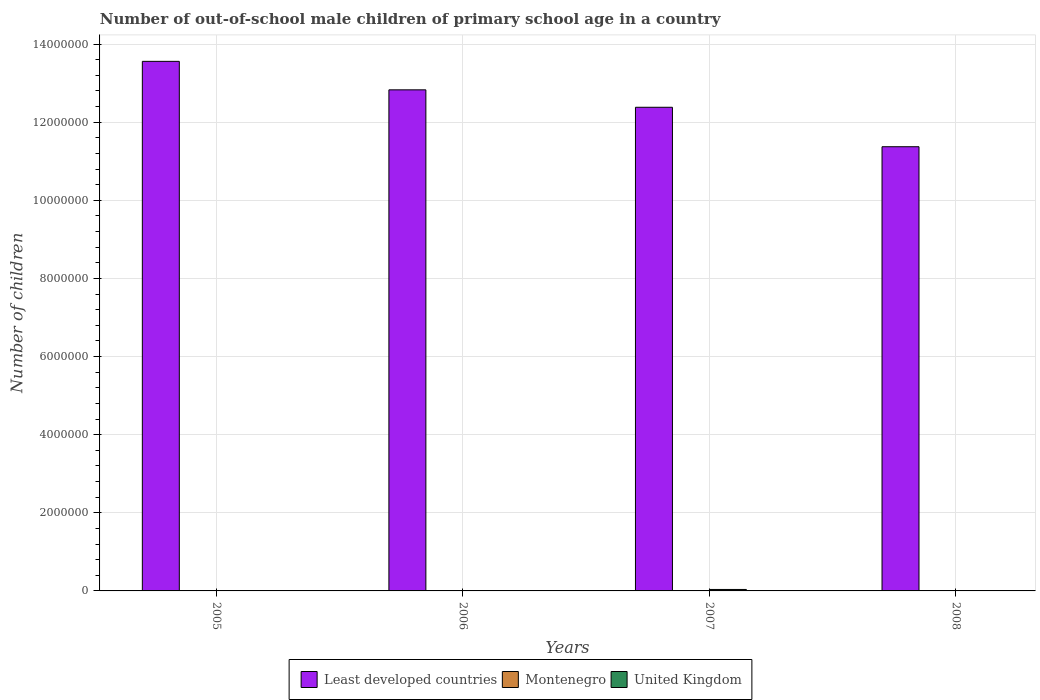Are the number of bars on each tick of the X-axis equal?
Ensure brevity in your answer.  Yes. How many bars are there on the 3rd tick from the left?
Keep it short and to the point. 3. How many bars are there on the 4th tick from the right?
Ensure brevity in your answer.  3. What is the label of the 4th group of bars from the left?
Give a very brief answer. 2008. What is the number of out-of-school male children in Least developed countries in 2005?
Provide a short and direct response. 1.36e+07. Across all years, what is the maximum number of out-of-school male children in Least developed countries?
Offer a very short reply. 1.36e+07. Across all years, what is the minimum number of out-of-school male children in Montenegro?
Your response must be concise. 218. In which year was the number of out-of-school male children in Least developed countries maximum?
Your response must be concise. 2005. What is the total number of out-of-school male children in United Kingdom in the graph?
Keep it short and to the point. 5.07e+04. What is the difference between the number of out-of-school male children in Montenegro in 2005 and that in 2007?
Your answer should be very brief. -359. What is the difference between the number of out-of-school male children in United Kingdom in 2007 and the number of out-of-school male children in Least developed countries in 2008?
Give a very brief answer. -1.13e+07. What is the average number of out-of-school male children in Montenegro per year?
Your answer should be compact. 469.25. In the year 2007, what is the difference between the number of out-of-school male children in Least developed countries and number of out-of-school male children in United Kingdom?
Offer a very short reply. 1.23e+07. In how many years, is the number of out-of-school male children in Least developed countries greater than 5600000?
Your answer should be compact. 4. What is the ratio of the number of out-of-school male children in United Kingdom in 2005 to that in 2006?
Give a very brief answer. 0. What is the difference between the highest and the second highest number of out-of-school male children in United Kingdom?
Provide a succinct answer. 2.65e+04. What is the difference between the highest and the lowest number of out-of-school male children in United Kingdom?
Your answer should be very brief. 3.72e+04. What does the 1st bar from the left in 2006 represents?
Make the answer very short. Least developed countries. What does the 2nd bar from the right in 2007 represents?
Keep it short and to the point. Montenegro. How many years are there in the graph?
Offer a terse response. 4. Does the graph contain any zero values?
Make the answer very short. No. Does the graph contain grids?
Your answer should be compact. Yes. How many legend labels are there?
Ensure brevity in your answer.  3. How are the legend labels stacked?
Keep it short and to the point. Horizontal. What is the title of the graph?
Keep it short and to the point. Number of out-of-school male children of primary school age in a country. Does "Sao Tome and Principe" appear as one of the legend labels in the graph?
Keep it short and to the point. No. What is the label or title of the X-axis?
Ensure brevity in your answer.  Years. What is the label or title of the Y-axis?
Your response must be concise. Number of children. What is the Number of children of Least developed countries in 2005?
Your answer should be compact. 1.36e+07. What is the Number of children of Montenegro in 2005?
Your answer should be compact. 317. What is the Number of children in Least developed countries in 2006?
Your answer should be compact. 1.28e+07. What is the Number of children in Montenegro in 2006?
Provide a short and direct response. 218. What is the Number of children of United Kingdom in 2006?
Offer a very short reply. 1.07e+04. What is the Number of children in Least developed countries in 2007?
Offer a very short reply. 1.24e+07. What is the Number of children in Montenegro in 2007?
Keep it short and to the point. 676. What is the Number of children of United Kingdom in 2007?
Ensure brevity in your answer.  3.72e+04. What is the Number of children in Least developed countries in 2008?
Provide a succinct answer. 1.14e+07. What is the Number of children of Montenegro in 2008?
Your answer should be compact. 666. What is the Number of children of United Kingdom in 2008?
Offer a very short reply. 2662. Across all years, what is the maximum Number of children in Least developed countries?
Offer a terse response. 1.36e+07. Across all years, what is the maximum Number of children of Montenegro?
Your response must be concise. 676. Across all years, what is the maximum Number of children of United Kingdom?
Make the answer very short. 3.72e+04. Across all years, what is the minimum Number of children of Least developed countries?
Your answer should be compact. 1.14e+07. Across all years, what is the minimum Number of children in Montenegro?
Your answer should be very brief. 218. What is the total Number of children in Least developed countries in the graph?
Offer a terse response. 5.01e+07. What is the total Number of children of Montenegro in the graph?
Offer a very short reply. 1877. What is the total Number of children in United Kingdom in the graph?
Make the answer very short. 5.07e+04. What is the difference between the Number of children of Least developed countries in 2005 and that in 2006?
Give a very brief answer. 7.29e+05. What is the difference between the Number of children of United Kingdom in 2005 and that in 2006?
Your answer should be very brief. -1.07e+04. What is the difference between the Number of children in Least developed countries in 2005 and that in 2007?
Provide a succinct answer. 1.18e+06. What is the difference between the Number of children in Montenegro in 2005 and that in 2007?
Keep it short and to the point. -359. What is the difference between the Number of children of United Kingdom in 2005 and that in 2007?
Give a very brief answer. -3.72e+04. What is the difference between the Number of children in Least developed countries in 2005 and that in 2008?
Provide a succinct answer. 2.19e+06. What is the difference between the Number of children in Montenegro in 2005 and that in 2008?
Offer a very short reply. -349. What is the difference between the Number of children of United Kingdom in 2005 and that in 2008?
Provide a succinct answer. -2620. What is the difference between the Number of children in Least developed countries in 2006 and that in 2007?
Offer a very short reply. 4.47e+05. What is the difference between the Number of children in Montenegro in 2006 and that in 2007?
Ensure brevity in your answer.  -458. What is the difference between the Number of children in United Kingdom in 2006 and that in 2007?
Give a very brief answer. -2.65e+04. What is the difference between the Number of children in Least developed countries in 2006 and that in 2008?
Offer a terse response. 1.46e+06. What is the difference between the Number of children of Montenegro in 2006 and that in 2008?
Your answer should be compact. -448. What is the difference between the Number of children of United Kingdom in 2006 and that in 2008?
Offer a very short reply. 8075. What is the difference between the Number of children of Least developed countries in 2007 and that in 2008?
Offer a very short reply. 1.01e+06. What is the difference between the Number of children in Montenegro in 2007 and that in 2008?
Provide a short and direct response. 10. What is the difference between the Number of children of United Kingdom in 2007 and that in 2008?
Your answer should be very brief. 3.46e+04. What is the difference between the Number of children of Least developed countries in 2005 and the Number of children of Montenegro in 2006?
Ensure brevity in your answer.  1.36e+07. What is the difference between the Number of children in Least developed countries in 2005 and the Number of children in United Kingdom in 2006?
Your response must be concise. 1.35e+07. What is the difference between the Number of children in Montenegro in 2005 and the Number of children in United Kingdom in 2006?
Your answer should be very brief. -1.04e+04. What is the difference between the Number of children of Least developed countries in 2005 and the Number of children of Montenegro in 2007?
Your answer should be very brief. 1.36e+07. What is the difference between the Number of children in Least developed countries in 2005 and the Number of children in United Kingdom in 2007?
Make the answer very short. 1.35e+07. What is the difference between the Number of children in Montenegro in 2005 and the Number of children in United Kingdom in 2007?
Your response must be concise. -3.69e+04. What is the difference between the Number of children in Least developed countries in 2005 and the Number of children in Montenegro in 2008?
Offer a terse response. 1.36e+07. What is the difference between the Number of children in Least developed countries in 2005 and the Number of children in United Kingdom in 2008?
Make the answer very short. 1.36e+07. What is the difference between the Number of children in Montenegro in 2005 and the Number of children in United Kingdom in 2008?
Provide a short and direct response. -2345. What is the difference between the Number of children in Least developed countries in 2006 and the Number of children in Montenegro in 2007?
Provide a short and direct response. 1.28e+07. What is the difference between the Number of children of Least developed countries in 2006 and the Number of children of United Kingdom in 2007?
Your answer should be very brief. 1.28e+07. What is the difference between the Number of children of Montenegro in 2006 and the Number of children of United Kingdom in 2007?
Make the answer very short. -3.70e+04. What is the difference between the Number of children in Least developed countries in 2006 and the Number of children in Montenegro in 2008?
Your answer should be compact. 1.28e+07. What is the difference between the Number of children of Least developed countries in 2006 and the Number of children of United Kingdom in 2008?
Offer a terse response. 1.28e+07. What is the difference between the Number of children in Montenegro in 2006 and the Number of children in United Kingdom in 2008?
Your response must be concise. -2444. What is the difference between the Number of children in Least developed countries in 2007 and the Number of children in Montenegro in 2008?
Your answer should be compact. 1.24e+07. What is the difference between the Number of children of Least developed countries in 2007 and the Number of children of United Kingdom in 2008?
Your response must be concise. 1.24e+07. What is the difference between the Number of children of Montenegro in 2007 and the Number of children of United Kingdom in 2008?
Keep it short and to the point. -1986. What is the average Number of children in Least developed countries per year?
Your response must be concise. 1.25e+07. What is the average Number of children in Montenegro per year?
Offer a very short reply. 469.25. What is the average Number of children in United Kingdom per year?
Give a very brief answer. 1.27e+04. In the year 2005, what is the difference between the Number of children in Least developed countries and Number of children in Montenegro?
Your response must be concise. 1.36e+07. In the year 2005, what is the difference between the Number of children in Least developed countries and Number of children in United Kingdom?
Your answer should be compact. 1.36e+07. In the year 2005, what is the difference between the Number of children of Montenegro and Number of children of United Kingdom?
Offer a terse response. 275. In the year 2006, what is the difference between the Number of children in Least developed countries and Number of children in Montenegro?
Keep it short and to the point. 1.28e+07. In the year 2006, what is the difference between the Number of children of Least developed countries and Number of children of United Kingdom?
Provide a succinct answer. 1.28e+07. In the year 2006, what is the difference between the Number of children in Montenegro and Number of children in United Kingdom?
Make the answer very short. -1.05e+04. In the year 2007, what is the difference between the Number of children of Least developed countries and Number of children of Montenegro?
Make the answer very short. 1.24e+07. In the year 2007, what is the difference between the Number of children of Least developed countries and Number of children of United Kingdom?
Offer a terse response. 1.23e+07. In the year 2007, what is the difference between the Number of children in Montenegro and Number of children in United Kingdom?
Make the answer very short. -3.66e+04. In the year 2008, what is the difference between the Number of children in Least developed countries and Number of children in Montenegro?
Offer a very short reply. 1.14e+07. In the year 2008, what is the difference between the Number of children of Least developed countries and Number of children of United Kingdom?
Make the answer very short. 1.14e+07. In the year 2008, what is the difference between the Number of children of Montenegro and Number of children of United Kingdom?
Ensure brevity in your answer.  -1996. What is the ratio of the Number of children in Least developed countries in 2005 to that in 2006?
Give a very brief answer. 1.06. What is the ratio of the Number of children in Montenegro in 2005 to that in 2006?
Ensure brevity in your answer.  1.45. What is the ratio of the Number of children of United Kingdom in 2005 to that in 2006?
Your answer should be very brief. 0. What is the ratio of the Number of children of Least developed countries in 2005 to that in 2007?
Give a very brief answer. 1.09. What is the ratio of the Number of children in Montenegro in 2005 to that in 2007?
Make the answer very short. 0.47. What is the ratio of the Number of children in United Kingdom in 2005 to that in 2007?
Provide a succinct answer. 0. What is the ratio of the Number of children of Least developed countries in 2005 to that in 2008?
Ensure brevity in your answer.  1.19. What is the ratio of the Number of children of Montenegro in 2005 to that in 2008?
Provide a short and direct response. 0.48. What is the ratio of the Number of children of United Kingdom in 2005 to that in 2008?
Provide a succinct answer. 0.02. What is the ratio of the Number of children in Least developed countries in 2006 to that in 2007?
Provide a short and direct response. 1.04. What is the ratio of the Number of children of Montenegro in 2006 to that in 2007?
Keep it short and to the point. 0.32. What is the ratio of the Number of children of United Kingdom in 2006 to that in 2007?
Your response must be concise. 0.29. What is the ratio of the Number of children of Least developed countries in 2006 to that in 2008?
Your answer should be compact. 1.13. What is the ratio of the Number of children in Montenegro in 2006 to that in 2008?
Provide a succinct answer. 0.33. What is the ratio of the Number of children of United Kingdom in 2006 to that in 2008?
Your answer should be very brief. 4.03. What is the ratio of the Number of children of Least developed countries in 2007 to that in 2008?
Keep it short and to the point. 1.09. What is the ratio of the Number of children of Montenegro in 2007 to that in 2008?
Offer a terse response. 1.01. What is the ratio of the Number of children in United Kingdom in 2007 to that in 2008?
Provide a short and direct response. 13.99. What is the difference between the highest and the second highest Number of children of Least developed countries?
Your answer should be compact. 7.29e+05. What is the difference between the highest and the second highest Number of children of Montenegro?
Offer a very short reply. 10. What is the difference between the highest and the second highest Number of children in United Kingdom?
Give a very brief answer. 2.65e+04. What is the difference between the highest and the lowest Number of children in Least developed countries?
Your answer should be compact. 2.19e+06. What is the difference between the highest and the lowest Number of children in Montenegro?
Offer a terse response. 458. What is the difference between the highest and the lowest Number of children in United Kingdom?
Provide a succinct answer. 3.72e+04. 